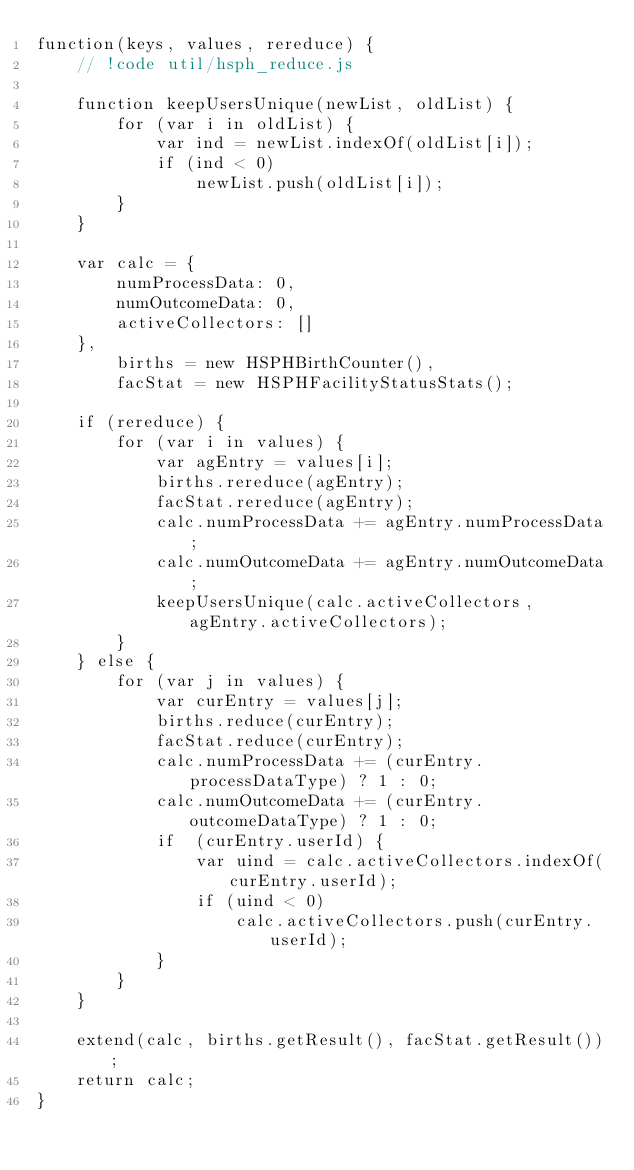Convert code to text. <code><loc_0><loc_0><loc_500><loc_500><_JavaScript_>function(keys, values, rereduce) {
    // !code util/hsph_reduce.js

    function keepUsersUnique(newList, oldList) {
        for (var i in oldList) {
            var ind = newList.indexOf(oldList[i]);
            if (ind < 0)
                newList.push(oldList[i]);
        }
    }

    var calc = {
        numProcessData: 0,
        numOutcomeData: 0,
        activeCollectors: []
    },
        births = new HSPHBirthCounter(),
        facStat = new HSPHFacilityStatusStats();

    if (rereduce) {
        for (var i in values) {
            var agEntry = values[i];
            births.rereduce(agEntry);
            facStat.rereduce(agEntry);
            calc.numProcessData += agEntry.numProcessData;
            calc.numOutcomeData += agEntry.numOutcomeData;
            keepUsersUnique(calc.activeCollectors, agEntry.activeCollectors);
        }
    } else {
        for (var j in values) {
            var curEntry = values[j];
            births.reduce(curEntry);
            facStat.reduce(curEntry);
            calc.numProcessData += (curEntry.processDataType) ? 1 : 0;
            calc.numOutcomeData += (curEntry.outcomeDataType) ? 1 : 0;
            if  (curEntry.userId) {
                var uind = calc.activeCollectors.indexOf(curEntry.userId);
                if (uind < 0)
                    calc.activeCollectors.push(curEntry.userId);
            }
        }
    }

    extend(calc, births.getResult(), facStat.getResult());
    return calc;
}</code> 